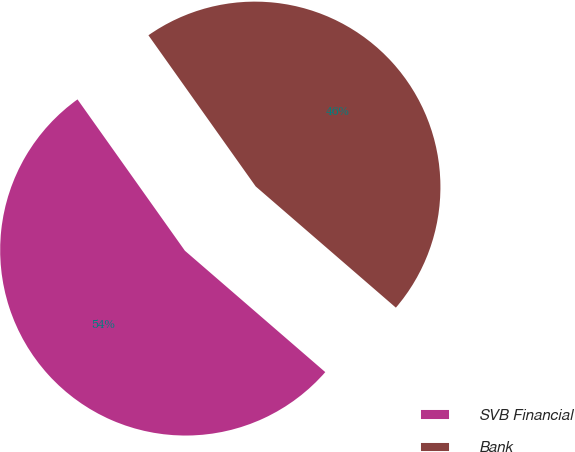Convert chart. <chart><loc_0><loc_0><loc_500><loc_500><pie_chart><fcel>SVB Financial<fcel>Bank<nl><fcel>53.83%<fcel>46.17%<nl></chart> 